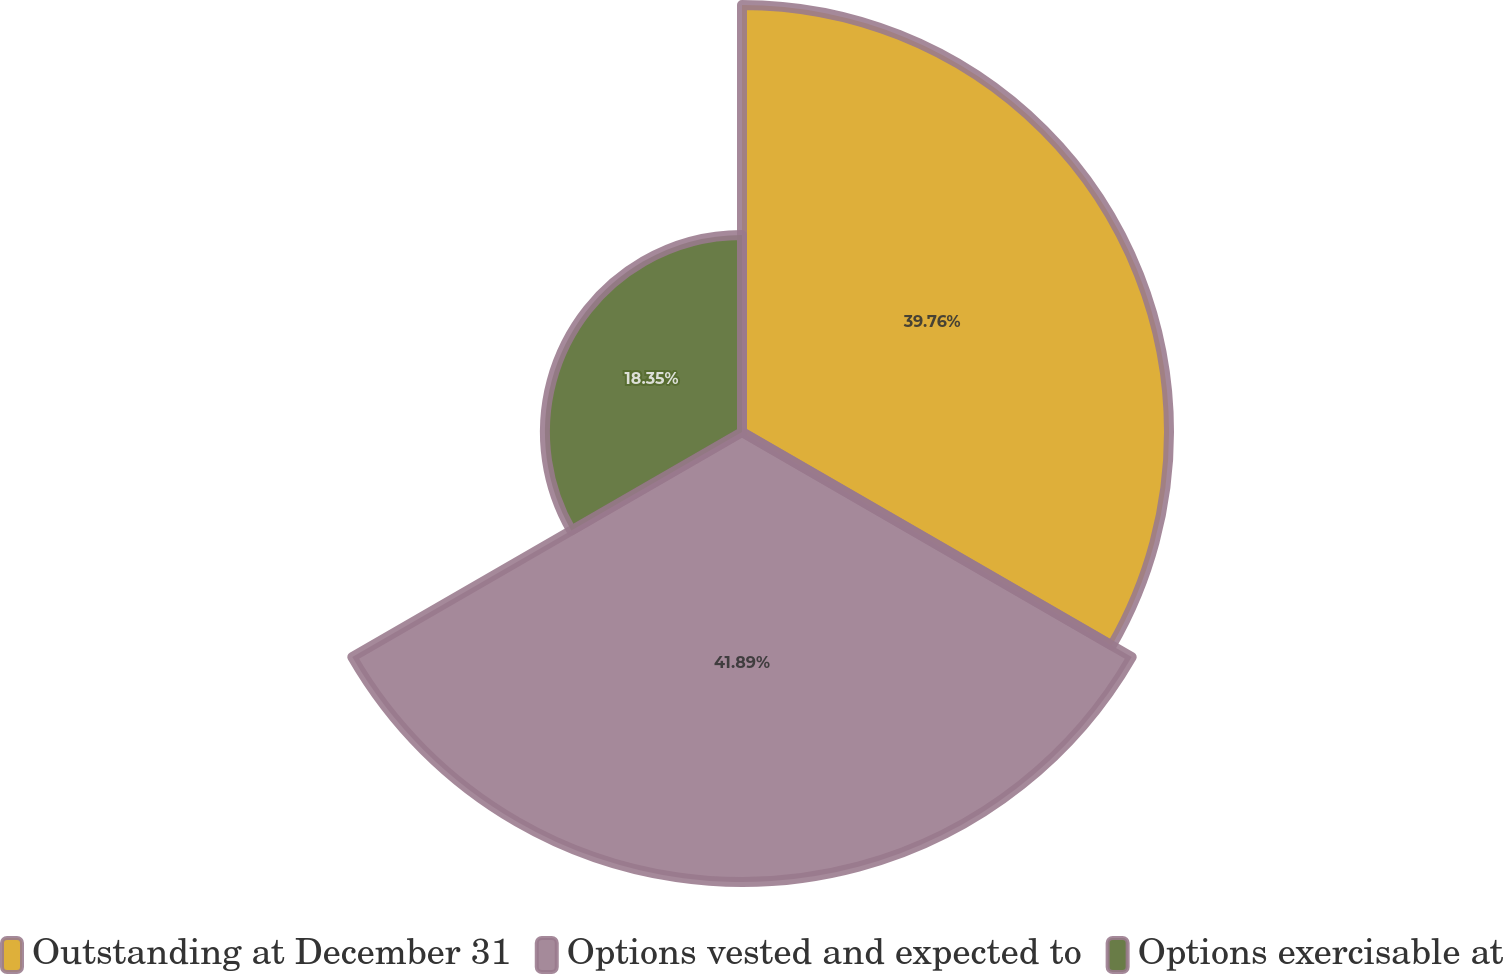<chart> <loc_0><loc_0><loc_500><loc_500><pie_chart><fcel>Outstanding at December 31<fcel>Options vested and expected to<fcel>Options exercisable at<nl><fcel>39.76%<fcel>41.9%<fcel>18.35%<nl></chart> 